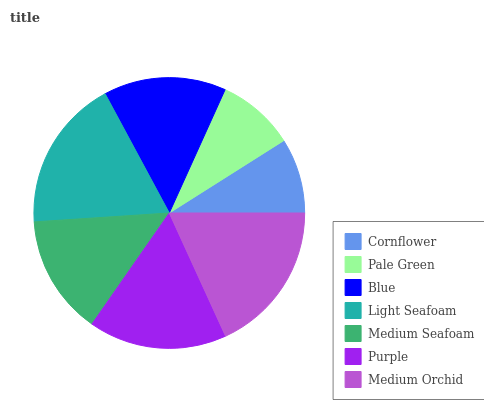Is Cornflower the minimum?
Answer yes or no. Yes. Is Light Seafoam the maximum?
Answer yes or no. Yes. Is Pale Green the minimum?
Answer yes or no. No. Is Pale Green the maximum?
Answer yes or no. No. Is Pale Green greater than Cornflower?
Answer yes or no. Yes. Is Cornflower less than Pale Green?
Answer yes or no. Yes. Is Cornflower greater than Pale Green?
Answer yes or no. No. Is Pale Green less than Cornflower?
Answer yes or no. No. Is Blue the high median?
Answer yes or no. Yes. Is Blue the low median?
Answer yes or no. Yes. Is Cornflower the high median?
Answer yes or no. No. Is Cornflower the low median?
Answer yes or no. No. 